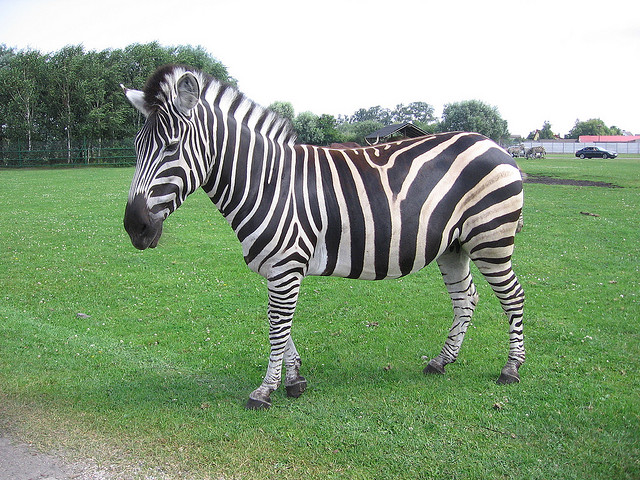<image>What do you think the Zebra is thinking? It is ambiguous to know what the Zebra is thinking. What do you think the Zebra is thinking? I am not sure what the Zebra is thinking. It can be thinking about being hungry or looking for food or water. 